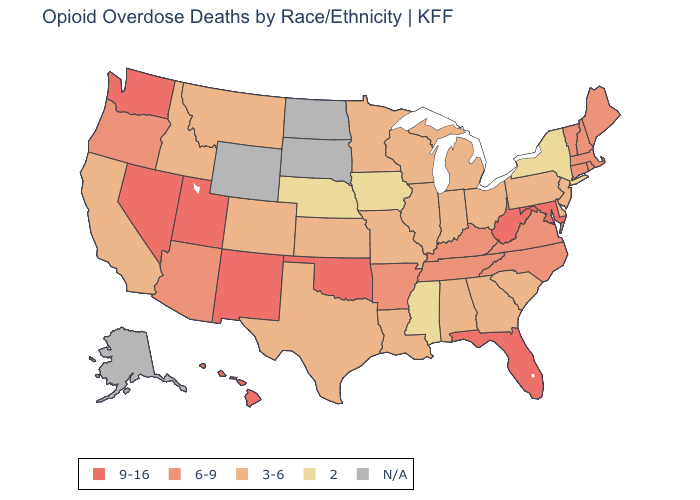Among the states that border Idaho , which have the highest value?
Quick response, please. Nevada, Utah, Washington. What is the lowest value in the USA?
Quick response, please. 2. Does the map have missing data?
Keep it brief. Yes. Among the states that border New Mexico , does Oklahoma have the highest value?
Write a very short answer. Yes. Does Indiana have the lowest value in the USA?
Keep it brief. No. Name the states that have a value in the range 6-9?
Answer briefly. Arizona, Arkansas, Connecticut, Kentucky, Maine, Massachusetts, New Hampshire, North Carolina, Oregon, Rhode Island, Tennessee, Vermont, Virginia. What is the value of Hawaii?
Quick response, please. 9-16. Name the states that have a value in the range 6-9?
Give a very brief answer. Arizona, Arkansas, Connecticut, Kentucky, Maine, Massachusetts, New Hampshire, North Carolina, Oregon, Rhode Island, Tennessee, Vermont, Virginia. Among the states that border New York , which have the highest value?
Concise answer only. Connecticut, Massachusetts, Vermont. Which states have the highest value in the USA?
Short answer required. Florida, Hawaii, Maryland, Nevada, New Mexico, Oklahoma, Utah, Washington, West Virginia. Does Missouri have the lowest value in the USA?
Give a very brief answer. No. Name the states that have a value in the range 9-16?
Keep it brief. Florida, Hawaii, Maryland, Nevada, New Mexico, Oklahoma, Utah, Washington, West Virginia. Does Oklahoma have the highest value in the USA?
Concise answer only. Yes. 